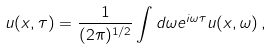<formula> <loc_0><loc_0><loc_500><loc_500>u ( x , \tau ) = \frac { 1 } { ( 2 \pi ) ^ { 1 / 2 } } \int d \omega e ^ { i \omega \tau } u ( x , \omega ) \, ,</formula> 